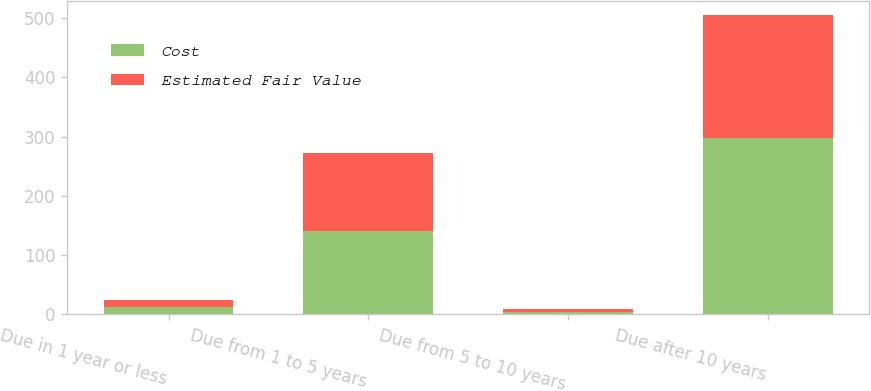<chart> <loc_0><loc_0><loc_500><loc_500><stacked_bar_chart><ecel><fcel>Due in 1 year or less<fcel>Due from 1 to 5 years<fcel>Due from 5 to 10 years<fcel>Due after 10 years<nl><fcel>Cost<fcel>13<fcel>141<fcel>5<fcel>298<nl><fcel>Estimated Fair Value<fcel>11<fcel>131<fcel>4<fcel>206<nl></chart> 